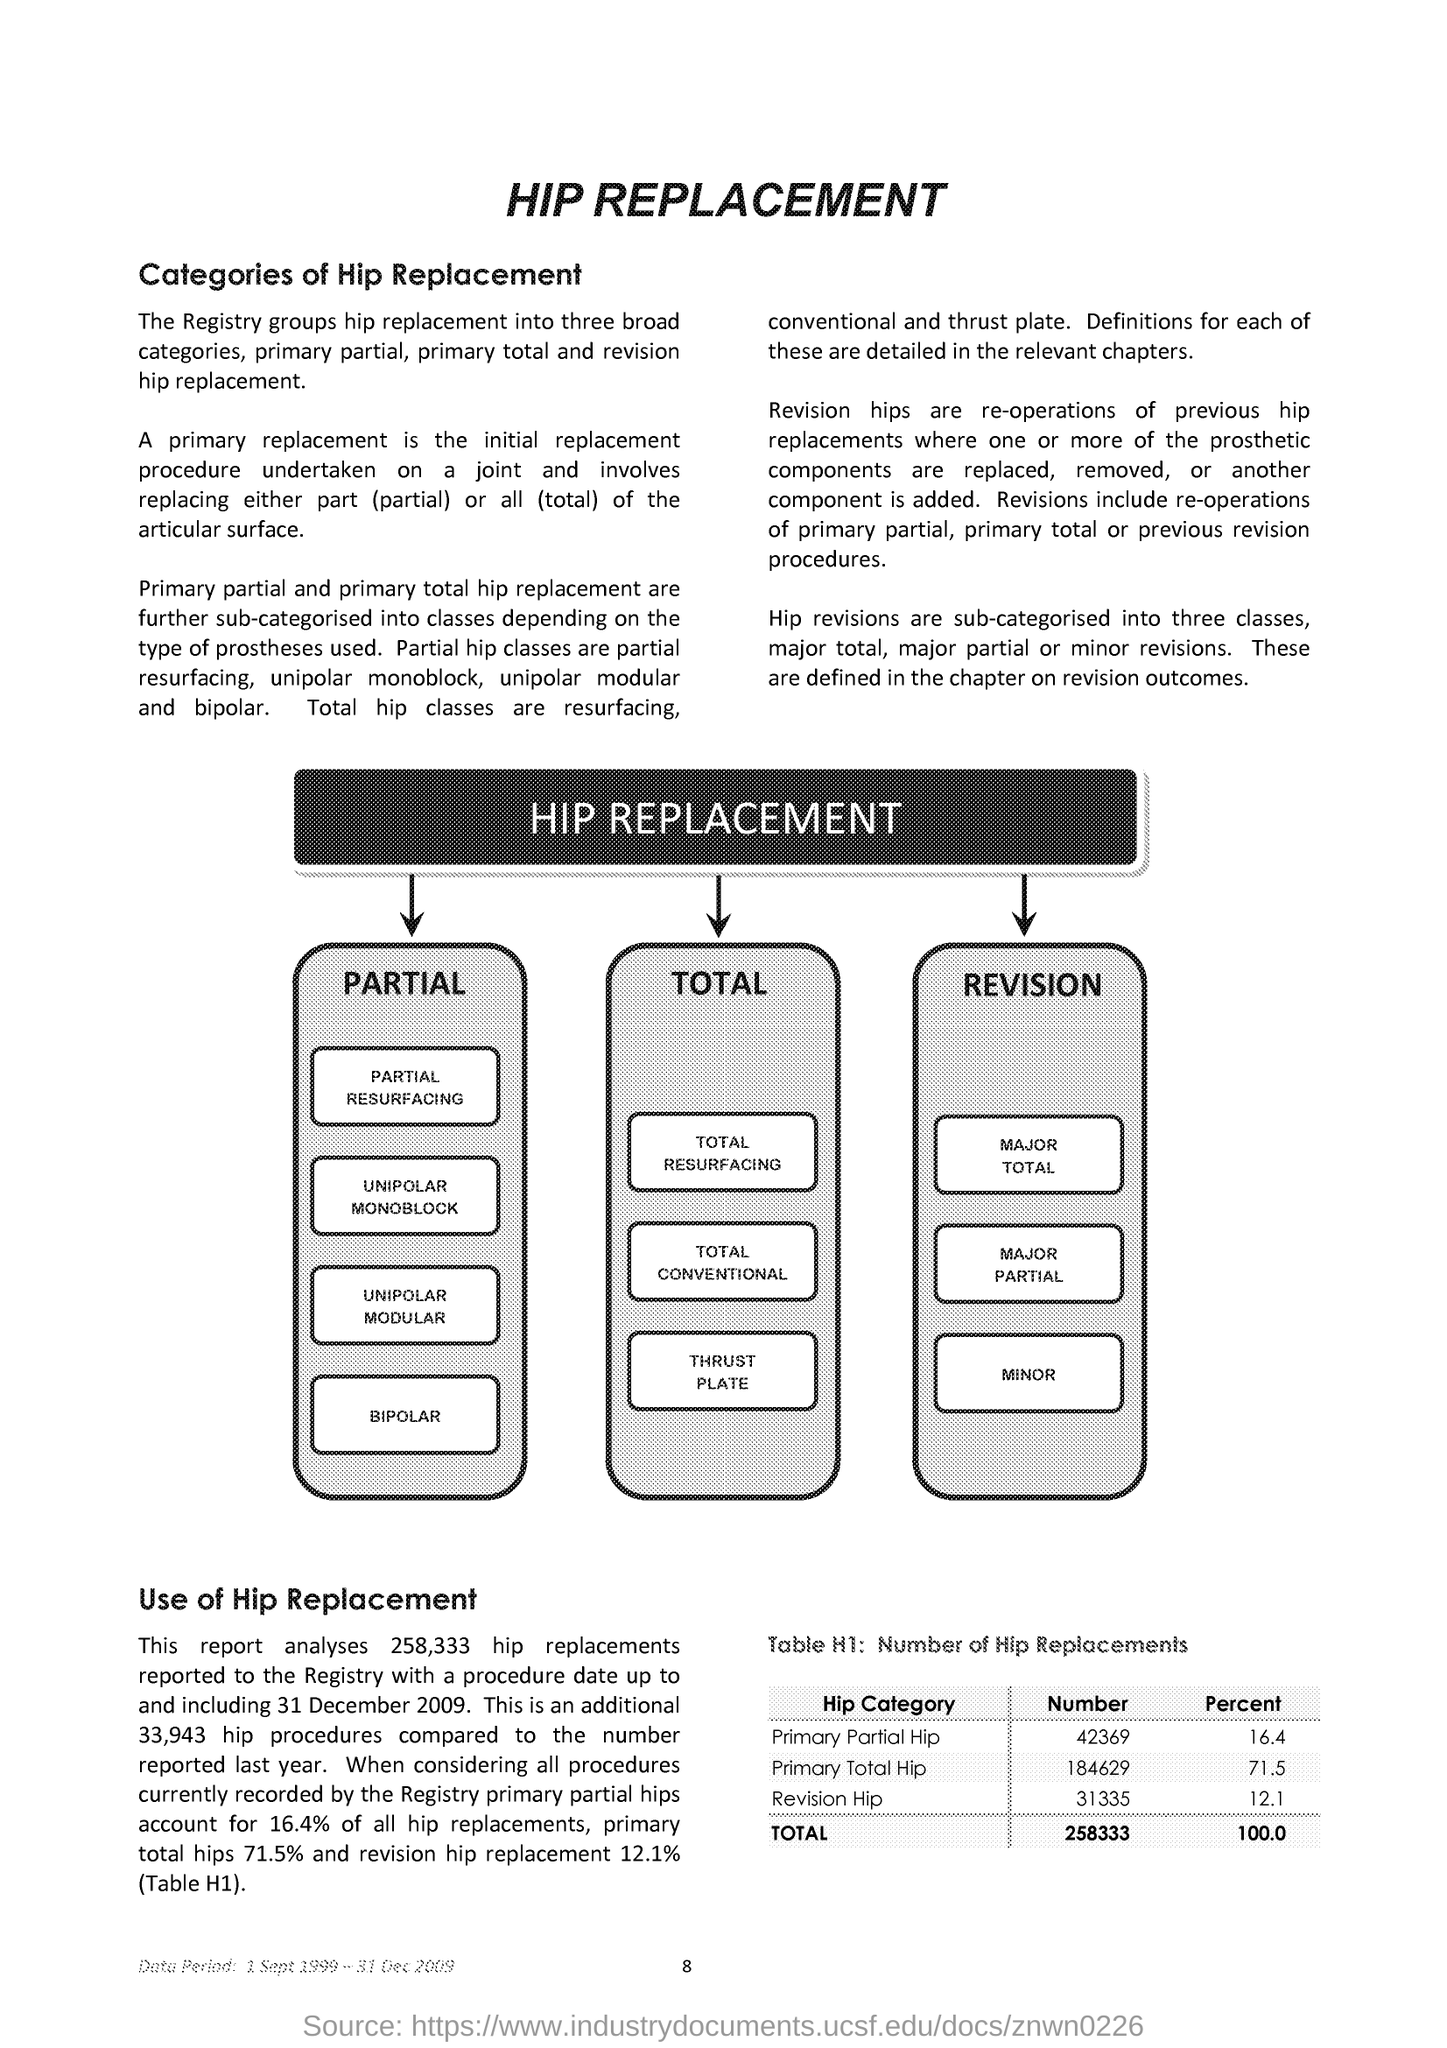Outline some significant characteristics in this image. Approximately 16.4% of hip replacements are partial hip replacements, with the majority of these being primary partial hip replacements. Approximately 71.5% of hip replacements are performed on primary total hips, which are the first time a patient has undergone hip replacement surgery. The total number of hip replacements reported is 258,333 as specified in Table H1. Table H1 provides a description of the number of hip replacements performed in a given time period. 